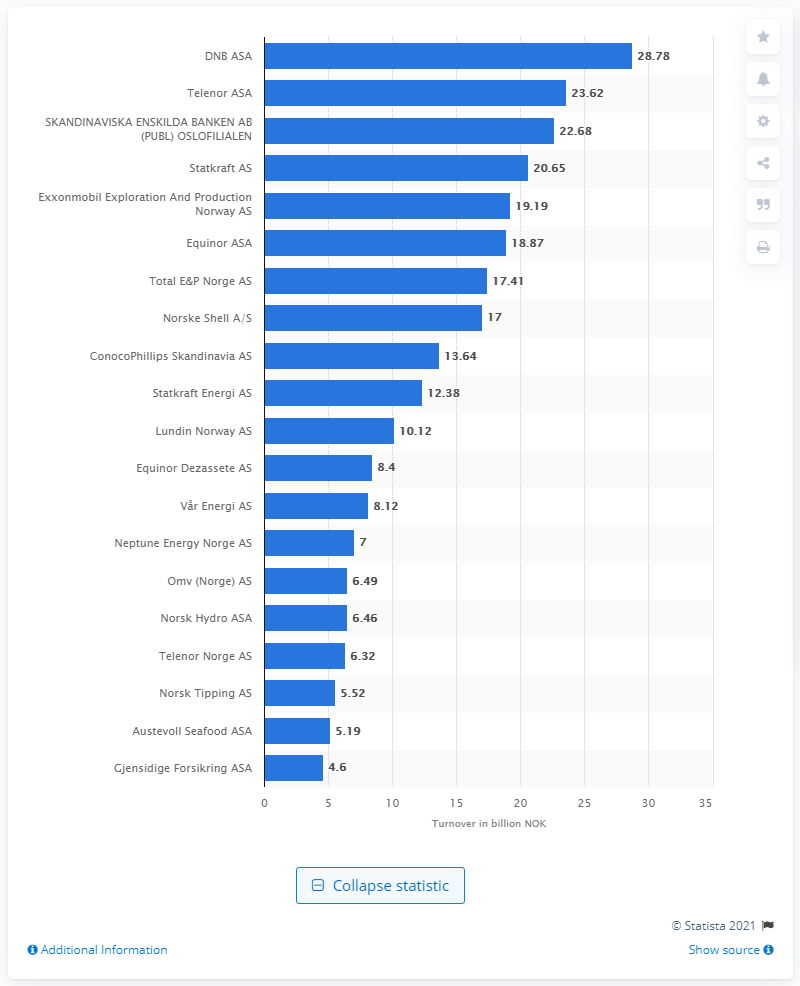List a handful of essential elements in this visual. DNB ASA's net profit for the month of July 2020 was NOK 28.78 million. 